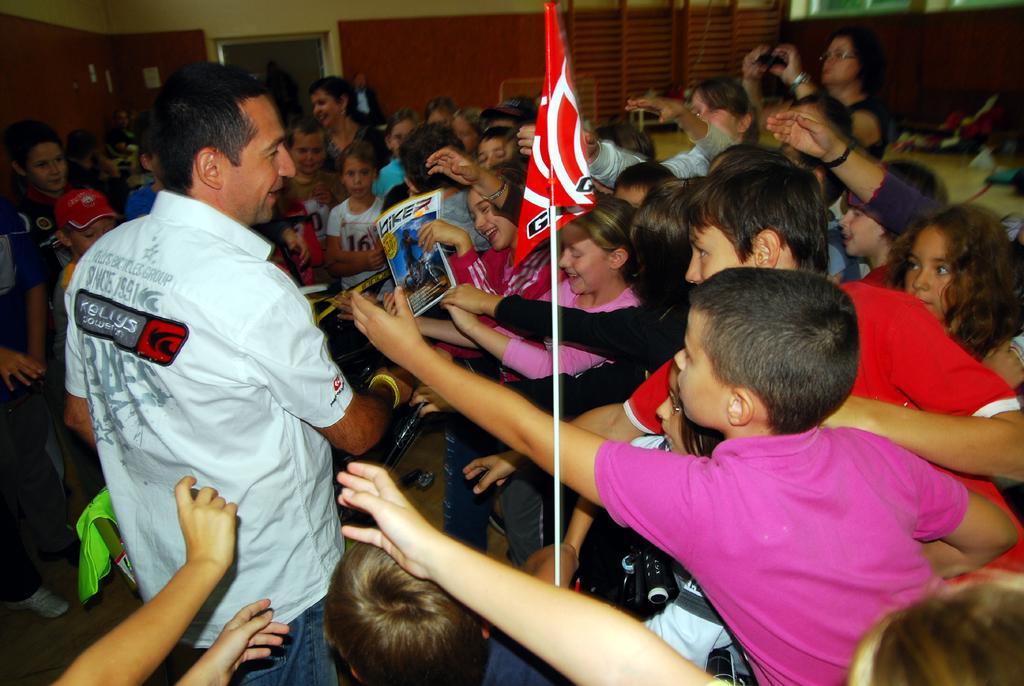Can you describe this image briefly? In this image I can see number of people and children are standing. In the front I can see a red colour flag and I can see this image is little bit blurry in the background. 